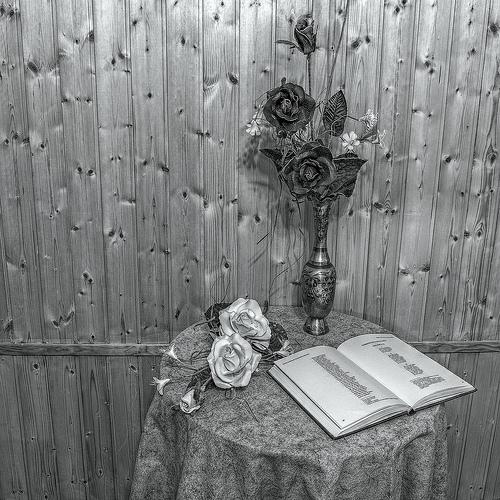Question: what is in the vase?
Choices:
A. Peonies.
B. Nothing.
C. Roses.
D. California Poppies.
Answer with the letter. Answer: C Question: what is on the table?
Choices:
A. Flowers, a book, and a laptop computer.
B. Nothing.
C. Dinner setting for 8 people.
D. Flowers, a vase of flowers, a book and a tablecloth.
Answer with the letter. Answer: D Question: what are the darker roses in?
Choices:
A. A deliver box.
B. A vase.
C. Nothing.
D. An ornate bowl.
Answer with the letter. Answer: B Question: what kind of photo is this?
Choices:
A. Color.
B. Sepia.
C. Warmly toned.
D. Black and white.
Answer with the letter. Answer: D Question: what is behind the table?
Choices:
A. A wall made of wood.
B. A fireplace and some firewood.
C. A grandfather clock made of wood.
D. A wall made of brick.
Answer with the letter. Answer: A 